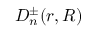Convert formula to latex. <formula><loc_0><loc_0><loc_500><loc_500>D _ { n } ^ { \pm } ( r , R )</formula> 